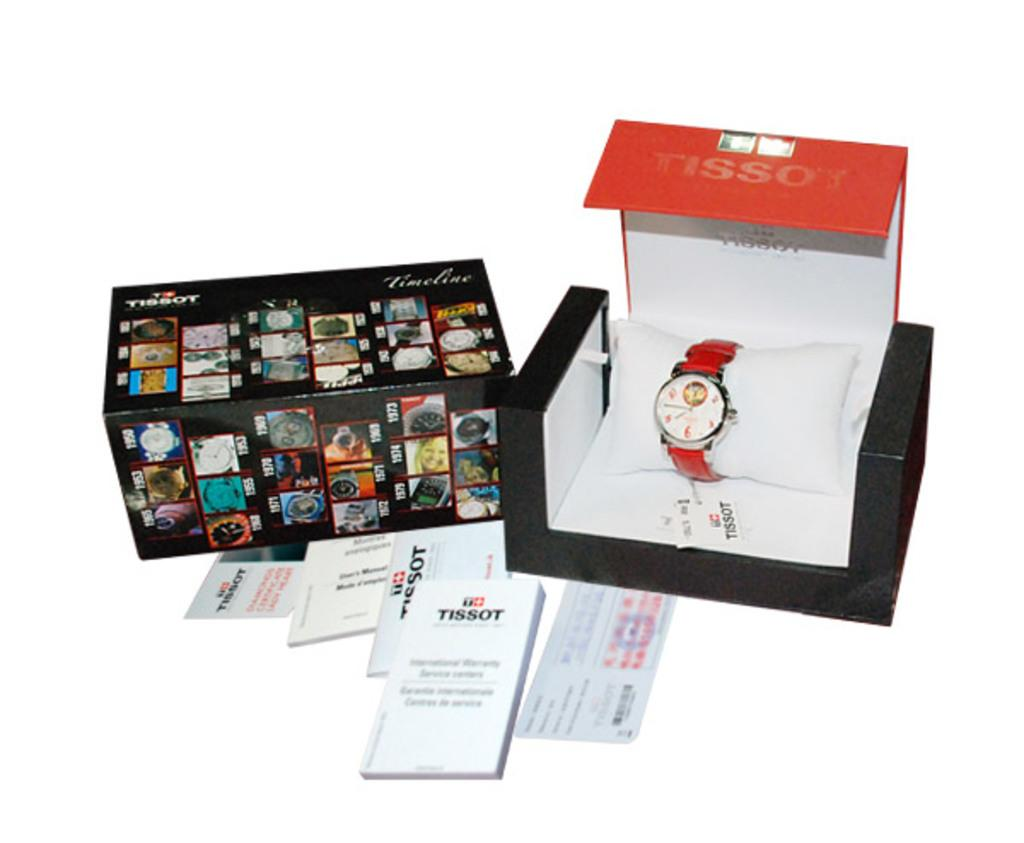Provide a one-sentence caption for the provided image. a box of a TISSOT watch with a red band. 